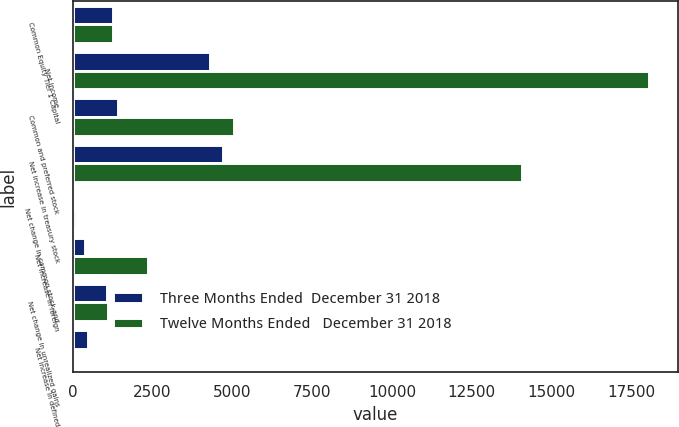Convert chart to OTSL. <chart><loc_0><loc_0><loc_500><loc_500><stacked_bar_chart><ecel><fcel>Common Equity Tier 1 Capital<fcel>Net income<fcel>Common and preferred stock<fcel>Net increase in treasury stock<fcel>Net change in common stock and<fcel>Net increase in foreign<fcel>Net change in unrealized gains<fcel>Net increase in defined<nl><fcel>Three Months Ended  December 31 2018<fcel>1247<fcel>4313<fcel>1402<fcel>4692<fcel>81<fcel>394<fcel>1072<fcel>489<nl><fcel>Twelve Months Ended   December 31 2018<fcel>1247<fcel>18045<fcel>5039<fcel>14061<fcel>102<fcel>2362<fcel>1092<fcel>74<nl></chart> 